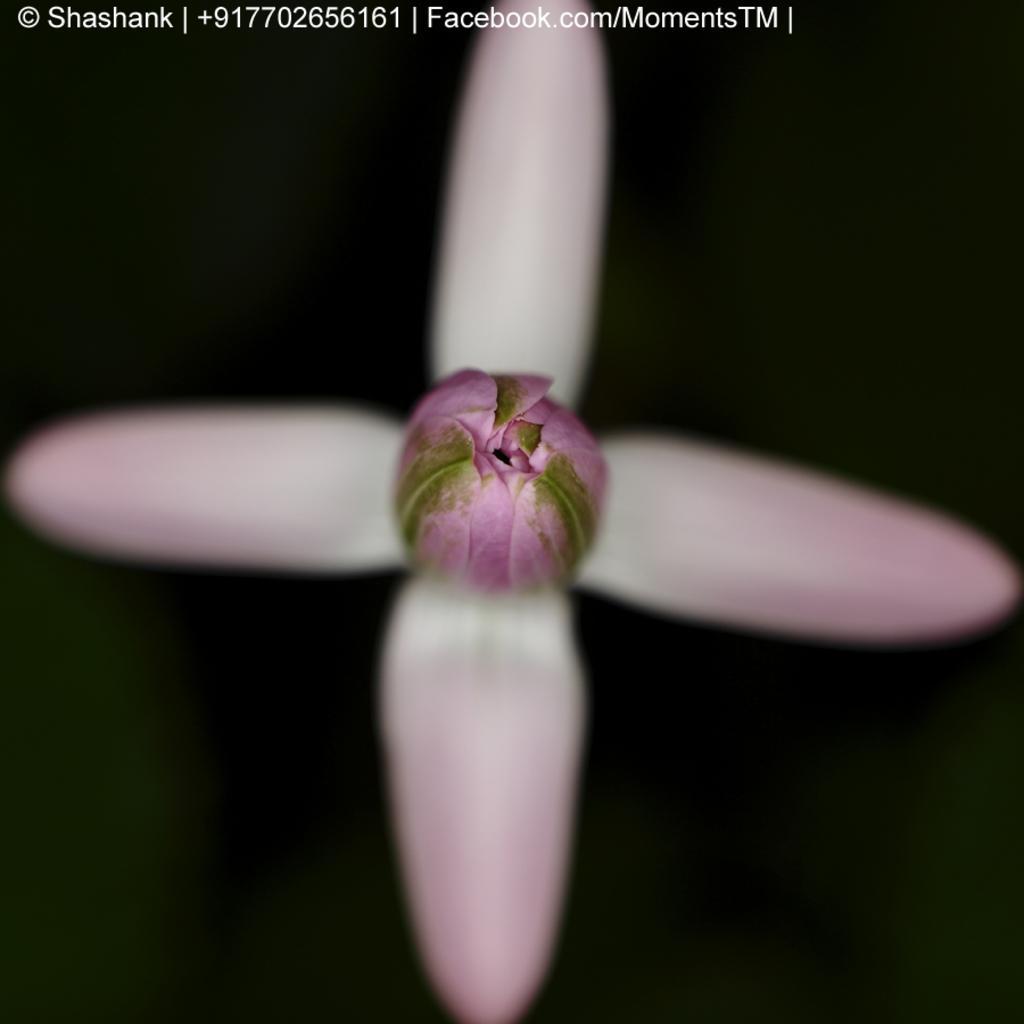Describe this image in one or two sentences. In the picture we can see the flower in the center of the image, the corners of the image is blurred and the background of the image is dark. Here we can see the watermark at the top of the image. 